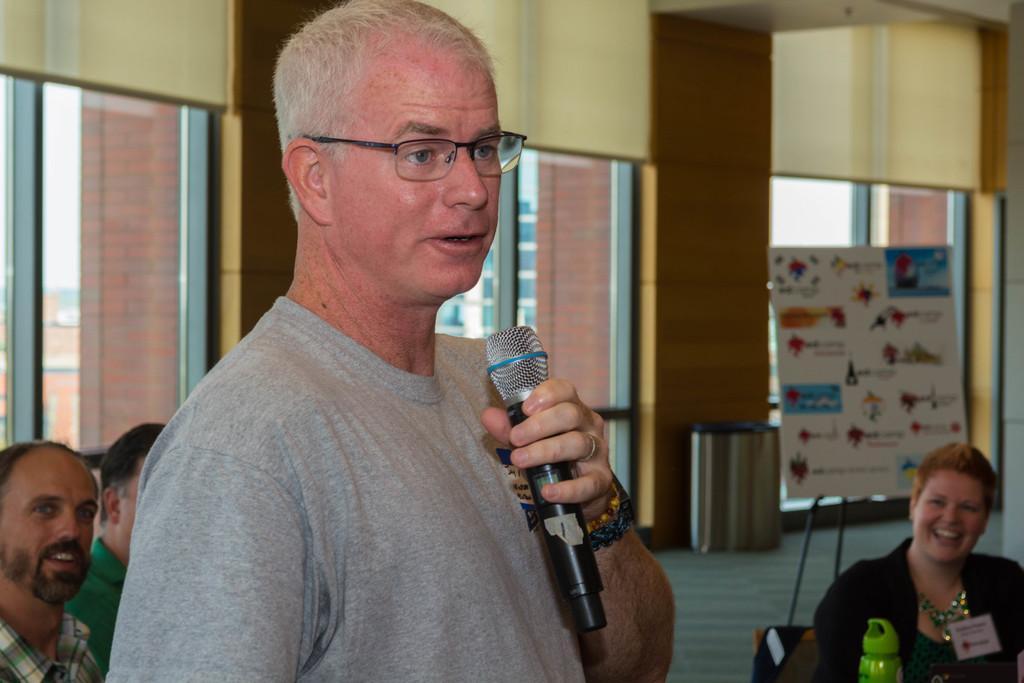Can you describe this image briefly? In this image I see a man who is wearing a t-shirt and I see that he is holding a mic in his hand. In the background I see 2 men and a woman over here and I see that these both of them are smiling and I see the windows and the wall and I see a board over here on which something is written. 